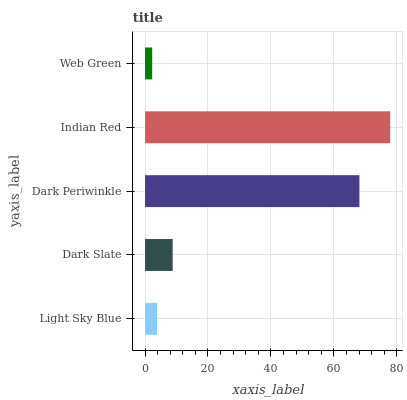Is Web Green the minimum?
Answer yes or no. Yes. Is Indian Red the maximum?
Answer yes or no. Yes. Is Dark Slate the minimum?
Answer yes or no. No. Is Dark Slate the maximum?
Answer yes or no. No. Is Dark Slate greater than Light Sky Blue?
Answer yes or no. Yes. Is Light Sky Blue less than Dark Slate?
Answer yes or no. Yes. Is Light Sky Blue greater than Dark Slate?
Answer yes or no. No. Is Dark Slate less than Light Sky Blue?
Answer yes or no. No. Is Dark Slate the high median?
Answer yes or no. Yes. Is Dark Slate the low median?
Answer yes or no. Yes. Is Light Sky Blue the high median?
Answer yes or no. No. Is Indian Red the low median?
Answer yes or no. No. 